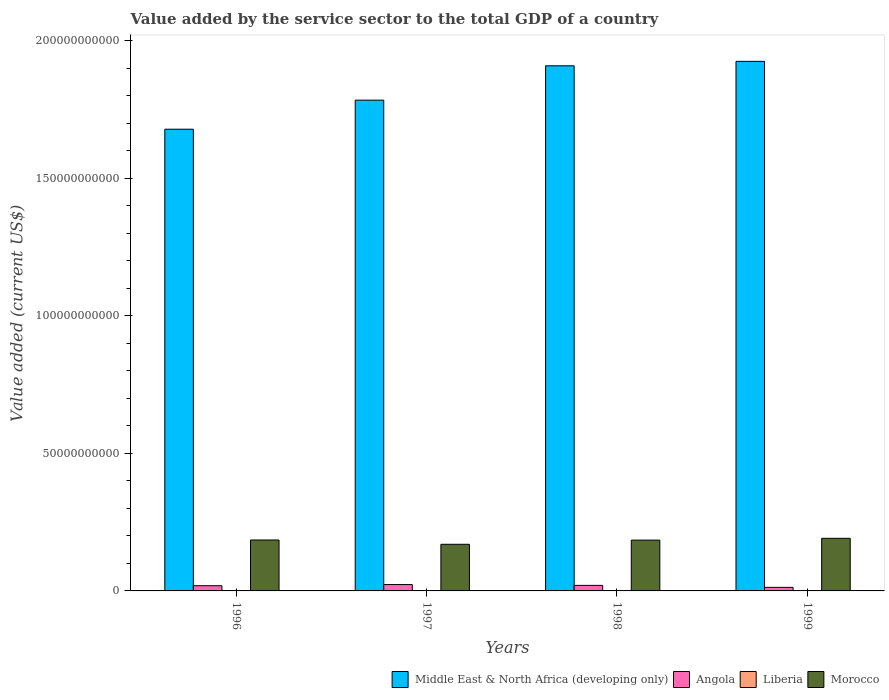How many different coloured bars are there?
Offer a terse response. 4. How many groups of bars are there?
Your answer should be very brief. 4. Are the number of bars per tick equal to the number of legend labels?
Provide a succinct answer. Yes. How many bars are there on the 3rd tick from the left?
Offer a terse response. 4. How many bars are there on the 1st tick from the right?
Keep it short and to the point. 4. In how many cases, is the number of bars for a given year not equal to the number of legend labels?
Your answer should be compact. 0. What is the value added by the service sector to the total GDP in Morocco in 1999?
Provide a short and direct response. 1.91e+1. Across all years, what is the maximum value added by the service sector to the total GDP in Liberia?
Provide a short and direct response. 7.34e+07. Across all years, what is the minimum value added by the service sector to the total GDP in Morocco?
Your response must be concise. 1.70e+1. What is the total value added by the service sector to the total GDP in Morocco in the graph?
Your answer should be very brief. 7.31e+1. What is the difference between the value added by the service sector to the total GDP in Morocco in 1997 and that in 1998?
Ensure brevity in your answer.  -1.51e+09. What is the difference between the value added by the service sector to the total GDP in Angola in 1997 and the value added by the service sector to the total GDP in Liberia in 1996?
Your answer should be very brief. 2.31e+09. What is the average value added by the service sector to the total GDP in Morocco per year?
Offer a terse response. 1.83e+1. In the year 1997, what is the difference between the value added by the service sector to the total GDP in Angola and value added by the service sector to the total GDP in Morocco?
Give a very brief answer. -1.46e+1. What is the ratio of the value added by the service sector to the total GDP in Morocco in 1996 to that in 1998?
Keep it short and to the point. 1. Is the value added by the service sector to the total GDP in Angola in 1997 less than that in 1999?
Keep it short and to the point. No. What is the difference between the highest and the second highest value added by the service sector to the total GDP in Liberia?
Ensure brevity in your answer.  2.21e+07. What is the difference between the highest and the lowest value added by the service sector to the total GDP in Morocco?
Your answer should be very brief. 2.17e+09. Is the sum of the value added by the service sector to the total GDP in Angola in 1997 and 1998 greater than the maximum value added by the service sector to the total GDP in Liberia across all years?
Keep it short and to the point. Yes. What does the 1st bar from the left in 1999 represents?
Your answer should be very brief. Middle East & North Africa (developing only). What does the 3rd bar from the right in 1999 represents?
Provide a succinct answer. Angola. Is it the case that in every year, the sum of the value added by the service sector to the total GDP in Middle East & North Africa (developing only) and value added by the service sector to the total GDP in Angola is greater than the value added by the service sector to the total GDP in Morocco?
Your response must be concise. Yes. How many bars are there?
Offer a terse response. 16. Are all the bars in the graph horizontal?
Your answer should be very brief. No. What is the difference between two consecutive major ticks on the Y-axis?
Your answer should be very brief. 5.00e+1. Does the graph contain grids?
Provide a succinct answer. No. How many legend labels are there?
Keep it short and to the point. 4. How are the legend labels stacked?
Provide a short and direct response. Horizontal. What is the title of the graph?
Offer a very short reply. Value added by the service sector to the total GDP of a country. What is the label or title of the Y-axis?
Provide a succinct answer. Value added (current US$). What is the Value added (current US$) of Middle East & North Africa (developing only) in 1996?
Your answer should be very brief. 1.68e+11. What is the Value added (current US$) of Angola in 1996?
Make the answer very short. 1.89e+09. What is the Value added (current US$) of Liberia in 1996?
Provide a succinct answer. 6.60e+06. What is the Value added (current US$) of Morocco in 1996?
Your answer should be very brief. 1.85e+1. What is the Value added (current US$) of Middle East & North Africa (developing only) in 1997?
Give a very brief answer. 1.78e+11. What is the Value added (current US$) of Angola in 1997?
Keep it short and to the point. 2.31e+09. What is the Value added (current US$) of Liberia in 1997?
Your answer should be very brief. 3.79e+07. What is the Value added (current US$) of Morocco in 1997?
Your answer should be compact. 1.70e+1. What is the Value added (current US$) of Middle East & North Africa (developing only) in 1998?
Ensure brevity in your answer.  1.91e+11. What is the Value added (current US$) of Angola in 1998?
Ensure brevity in your answer.  2.02e+09. What is the Value added (current US$) of Liberia in 1998?
Make the answer very short. 5.13e+07. What is the Value added (current US$) in Morocco in 1998?
Offer a terse response. 1.85e+1. What is the Value added (current US$) of Middle East & North Africa (developing only) in 1999?
Provide a short and direct response. 1.93e+11. What is the Value added (current US$) in Angola in 1999?
Provide a short and direct response. 1.29e+09. What is the Value added (current US$) of Liberia in 1999?
Your answer should be very brief. 7.34e+07. What is the Value added (current US$) of Morocco in 1999?
Your answer should be compact. 1.91e+1. Across all years, what is the maximum Value added (current US$) of Middle East & North Africa (developing only)?
Offer a terse response. 1.93e+11. Across all years, what is the maximum Value added (current US$) in Angola?
Provide a short and direct response. 2.31e+09. Across all years, what is the maximum Value added (current US$) in Liberia?
Your answer should be very brief. 7.34e+07. Across all years, what is the maximum Value added (current US$) of Morocco?
Keep it short and to the point. 1.91e+1. Across all years, what is the minimum Value added (current US$) of Middle East & North Africa (developing only)?
Your answer should be compact. 1.68e+11. Across all years, what is the minimum Value added (current US$) of Angola?
Give a very brief answer. 1.29e+09. Across all years, what is the minimum Value added (current US$) of Liberia?
Offer a terse response. 6.60e+06. Across all years, what is the minimum Value added (current US$) of Morocco?
Keep it short and to the point. 1.70e+1. What is the total Value added (current US$) of Middle East & North Africa (developing only) in the graph?
Your response must be concise. 7.30e+11. What is the total Value added (current US$) in Angola in the graph?
Your answer should be compact. 7.51e+09. What is the total Value added (current US$) in Liberia in the graph?
Your answer should be compact. 1.69e+08. What is the total Value added (current US$) of Morocco in the graph?
Offer a very short reply. 7.31e+1. What is the difference between the Value added (current US$) of Middle East & North Africa (developing only) in 1996 and that in 1997?
Your response must be concise. -1.06e+1. What is the difference between the Value added (current US$) of Angola in 1996 and that in 1997?
Ensure brevity in your answer.  -4.20e+08. What is the difference between the Value added (current US$) of Liberia in 1996 and that in 1997?
Offer a very short reply. -3.13e+07. What is the difference between the Value added (current US$) of Morocco in 1996 and that in 1997?
Ensure brevity in your answer.  1.56e+09. What is the difference between the Value added (current US$) in Middle East & North Africa (developing only) in 1996 and that in 1998?
Provide a short and direct response. -2.31e+1. What is the difference between the Value added (current US$) of Angola in 1996 and that in 1998?
Offer a very short reply. -1.23e+08. What is the difference between the Value added (current US$) in Liberia in 1996 and that in 1998?
Your answer should be very brief. -4.47e+07. What is the difference between the Value added (current US$) in Morocco in 1996 and that in 1998?
Your answer should be very brief. 4.87e+07. What is the difference between the Value added (current US$) in Middle East & North Africa (developing only) in 1996 and that in 1999?
Ensure brevity in your answer.  -2.47e+1. What is the difference between the Value added (current US$) in Angola in 1996 and that in 1999?
Your response must be concise. 6.02e+08. What is the difference between the Value added (current US$) of Liberia in 1996 and that in 1999?
Provide a short and direct response. -6.68e+07. What is the difference between the Value added (current US$) of Morocco in 1996 and that in 1999?
Offer a very short reply. -6.11e+08. What is the difference between the Value added (current US$) in Middle East & North Africa (developing only) in 1997 and that in 1998?
Provide a short and direct response. -1.25e+1. What is the difference between the Value added (current US$) of Angola in 1997 and that in 1998?
Your answer should be very brief. 2.97e+08. What is the difference between the Value added (current US$) of Liberia in 1997 and that in 1998?
Keep it short and to the point. -1.34e+07. What is the difference between the Value added (current US$) of Morocco in 1997 and that in 1998?
Ensure brevity in your answer.  -1.51e+09. What is the difference between the Value added (current US$) of Middle East & North Africa (developing only) in 1997 and that in 1999?
Offer a terse response. -1.41e+1. What is the difference between the Value added (current US$) of Angola in 1997 and that in 1999?
Keep it short and to the point. 1.02e+09. What is the difference between the Value added (current US$) in Liberia in 1997 and that in 1999?
Provide a succinct answer. -3.55e+07. What is the difference between the Value added (current US$) of Morocco in 1997 and that in 1999?
Provide a short and direct response. -2.17e+09. What is the difference between the Value added (current US$) in Middle East & North Africa (developing only) in 1998 and that in 1999?
Your answer should be very brief. -1.62e+09. What is the difference between the Value added (current US$) of Angola in 1998 and that in 1999?
Offer a very short reply. 7.25e+08. What is the difference between the Value added (current US$) in Liberia in 1998 and that in 1999?
Make the answer very short. -2.21e+07. What is the difference between the Value added (current US$) of Morocco in 1998 and that in 1999?
Keep it short and to the point. -6.60e+08. What is the difference between the Value added (current US$) of Middle East & North Africa (developing only) in 1996 and the Value added (current US$) of Angola in 1997?
Make the answer very short. 1.66e+11. What is the difference between the Value added (current US$) of Middle East & North Africa (developing only) in 1996 and the Value added (current US$) of Liberia in 1997?
Ensure brevity in your answer.  1.68e+11. What is the difference between the Value added (current US$) of Middle East & North Africa (developing only) in 1996 and the Value added (current US$) of Morocco in 1997?
Ensure brevity in your answer.  1.51e+11. What is the difference between the Value added (current US$) of Angola in 1996 and the Value added (current US$) of Liberia in 1997?
Keep it short and to the point. 1.86e+09. What is the difference between the Value added (current US$) in Angola in 1996 and the Value added (current US$) in Morocco in 1997?
Ensure brevity in your answer.  -1.51e+1. What is the difference between the Value added (current US$) of Liberia in 1996 and the Value added (current US$) of Morocco in 1997?
Your response must be concise. -1.70e+1. What is the difference between the Value added (current US$) in Middle East & North Africa (developing only) in 1996 and the Value added (current US$) in Angola in 1998?
Keep it short and to the point. 1.66e+11. What is the difference between the Value added (current US$) of Middle East & North Africa (developing only) in 1996 and the Value added (current US$) of Liberia in 1998?
Your response must be concise. 1.68e+11. What is the difference between the Value added (current US$) of Middle East & North Africa (developing only) in 1996 and the Value added (current US$) of Morocco in 1998?
Ensure brevity in your answer.  1.49e+11. What is the difference between the Value added (current US$) of Angola in 1996 and the Value added (current US$) of Liberia in 1998?
Offer a terse response. 1.84e+09. What is the difference between the Value added (current US$) in Angola in 1996 and the Value added (current US$) in Morocco in 1998?
Offer a terse response. -1.66e+1. What is the difference between the Value added (current US$) in Liberia in 1996 and the Value added (current US$) in Morocco in 1998?
Keep it short and to the point. -1.85e+1. What is the difference between the Value added (current US$) in Middle East & North Africa (developing only) in 1996 and the Value added (current US$) in Angola in 1999?
Your response must be concise. 1.67e+11. What is the difference between the Value added (current US$) in Middle East & North Africa (developing only) in 1996 and the Value added (current US$) in Liberia in 1999?
Provide a succinct answer. 1.68e+11. What is the difference between the Value added (current US$) of Middle East & North Africa (developing only) in 1996 and the Value added (current US$) of Morocco in 1999?
Your answer should be compact. 1.49e+11. What is the difference between the Value added (current US$) of Angola in 1996 and the Value added (current US$) of Liberia in 1999?
Provide a succinct answer. 1.82e+09. What is the difference between the Value added (current US$) of Angola in 1996 and the Value added (current US$) of Morocco in 1999?
Give a very brief answer. -1.72e+1. What is the difference between the Value added (current US$) of Liberia in 1996 and the Value added (current US$) of Morocco in 1999?
Offer a very short reply. -1.91e+1. What is the difference between the Value added (current US$) in Middle East & North Africa (developing only) in 1997 and the Value added (current US$) in Angola in 1998?
Make the answer very short. 1.76e+11. What is the difference between the Value added (current US$) of Middle East & North Africa (developing only) in 1997 and the Value added (current US$) of Liberia in 1998?
Offer a very short reply. 1.78e+11. What is the difference between the Value added (current US$) in Middle East & North Africa (developing only) in 1997 and the Value added (current US$) in Morocco in 1998?
Provide a short and direct response. 1.60e+11. What is the difference between the Value added (current US$) in Angola in 1997 and the Value added (current US$) in Liberia in 1998?
Your response must be concise. 2.26e+09. What is the difference between the Value added (current US$) of Angola in 1997 and the Value added (current US$) of Morocco in 1998?
Your response must be concise. -1.62e+1. What is the difference between the Value added (current US$) in Liberia in 1997 and the Value added (current US$) in Morocco in 1998?
Keep it short and to the point. -1.84e+1. What is the difference between the Value added (current US$) in Middle East & North Africa (developing only) in 1997 and the Value added (current US$) in Angola in 1999?
Your answer should be compact. 1.77e+11. What is the difference between the Value added (current US$) of Middle East & North Africa (developing only) in 1997 and the Value added (current US$) of Liberia in 1999?
Provide a succinct answer. 1.78e+11. What is the difference between the Value added (current US$) in Middle East & North Africa (developing only) in 1997 and the Value added (current US$) in Morocco in 1999?
Give a very brief answer. 1.59e+11. What is the difference between the Value added (current US$) of Angola in 1997 and the Value added (current US$) of Liberia in 1999?
Your answer should be very brief. 2.24e+09. What is the difference between the Value added (current US$) of Angola in 1997 and the Value added (current US$) of Morocco in 1999?
Provide a succinct answer. -1.68e+1. What is the difference between the Value added (current US$) in Liberia in 1997 and the Value added (current US$) in Morocco in 1999?
Provide a short and direct response. -1.91e+1. What is the difference between the Value added (current US$) of Middle East & North Africa (developing only) in 1998 and the Value added (current US$) of Angola in 1999?
Your answer should be very brief. 1.90e+11. What is the difference between the Value added (current US$) of Middle East & North Africa (developing only) in 1998 and the Value added (current US$) of Liberia in 1999?
Provide a short and direct response. 1.91e+11. What is the difference between the Value added (current US$) of Middle East & North Africa (developing only) in 1998 and the Value added (current US$) of Morocco in 1999?
Ensure brevity in your answer.  1.72e+11. What is the difference between the Value added (current US$) in Angola in 1998 and the Value added (current US$) in Liberia in 1999?
Offer a terse response. 1.94e+09. What is the difference between the Value added (current US$) in Angola in 1998 and the Value added (current US$) in Morocco in 1999?
Provide a succinct answer. -1.71e+1. What is the difference between the Value added (current US$) in Liberia in 1998 and the Value added (current US$) in Morocco in 1999?
Your answer should be very brief. -1.91e+1. What is the average Value added (current US$) of Middle East & North Africa (developing only) per year?
Your answer should be compact. 1.82e+11. What is the average Value added (current US$) in Angola per year?
Ensure brevity in your answer.  1.88e+09. What is the average Value added (current US$) of Liberia per year?
Your answer should be very brief. 4.23e+07. What is the average Value added (current US$) of Morocco per year?
Ensure brevity in your answer.  1.83e+1. In the year 1996, what is the difference between the Value added (current US$) in Middle East & North Africa (developing only) and Value added (current US$) in Angola?
Offer a terse response. 1.66e+11. In the year 1996, what is the difference between the Value added (current US$) of Middle East & North Africa (developing only) and Value added (current US$) of Liberia?
Offer a terse response. 1.68e+11. In the year 1996, what is the difference between the Value added (current US$) in Middle East & North Africa (developing only) and Value added (current US$) in Morocco?
Keep it short and to the point. 1.49e+11. In the year 1996, what is the difference between the Value added (current US$) of Angola and Value added (current US$) of Liberia?
Provide a short and direct response. 1.89e+09. In the year 1996, what is the difference between the Value added (current US$) of Angola and Value added (current US$) of Morocco?
Provide a succinct answer. -1.66e+1. In the year 1996, what is the difference between the Value added (current US$) in Liberia and Value added (current US$) in Morocco?
Your answer should be compact. -1.85e+1. In the year 1997, what is the difference between the Value added (current US$) of Middle East & North Africa (developing only) and Value added (current US$) of Angola?
Your answer should be very brief. 1.76e+11. In the year 1997, what is the difference between the Value added (current US$) in Middle East & North Africa (developing only) and Value added (current US$) in Liberia?
Provide a succinct answer. 1.78e+11. In the year 1997, what is the difference between the Value added (current US$) of Middle East & North Africa (developing only) and Value added (current US$) of Morocco?
Give a very brief answer. 1.62e+11. In the year 1997, what is the difference between the Value added (current US$) in Angola and Value added (current US$) in Liberia?
Make the answer very short. 2.28e+09. In the year 1997, what is the difference between the Value added (current US$) in Angola and Value added (current US$) in Morocco?
Provide a succinct answer. -1.46e+1. In the year 1997, what is the difference between the Value added (current US$) in Liberia and Value added (current US$) in Morocco?
Provide a succinct answer. -1.69e+1. In the year 1998, what is the difference between the Value added (current US$) of Middle East & North Africa (developing only) and Value added (current US$) of Angola?
Give a very brief answer. 1.89e+11. In the year 1998, what is the difference between the Value added (current US$) of Middle East & North Africa (developing only) and Value added (current US$) of Liberia?
Make the answer very short. 1.91e+11. In the year 1998, what is the difference between the Value added (current US$) in Middle East & North Africa (developing only) and Value added (current US$) in Morocco?
Your response must be concise. 1.72e+11. In the year 1998, what is the difference between the Value added (current US$) in Angola and Value added (current US$) in Liberia?
Your answer should be very brief. 1.97e+09. In the year 1998, what is the difference between the Value added (current US$) in Angola and Value added (current US$) in Morocco?
Provide a short and direct response. -1.65e+1. In the year 1998, what is the difference between the Value added (current US$) of Liberia and Value added (current US$) of Morocco?
Provide a succinct answer. -1.84e+1. In the year 1999, what is the difference between the Value added (current US$) of Middle East & North Africa (developing only) and Value added (current US$) of Angola?
Offer a very short reply. 1.91e+11. In the year 1999, what is the difference between the Value added (current US$) in Middle East & North Africa (developing only) and Value added (current US$) in Liberia?
Keep it short and to the point. 1.93e+11. In the year 1999, what is the difference between the Value added (current US$) in Middle East & North Africa (developing only) and Value added (current US$) in Morocco?
Ensure brevity in your answer.  1.73e+11. In the year 1999, what is the difference between the Value added (current US$) of Angola and Value added (current US$) of Liberia?
Ensure brevity in your answer.  1.22e+09. In the year 1999, what is the difference between the Value added (current US$) of Angola and Value added (current US$) of Morocco?
Ensure brevity in your answer.  -1.78e+1. In the year 1999, what is the difference between the Value added (current US$) of Liberia and Value added (current US$) of Morocco?
Offer a terse response. -1.91e+1. What is the ratio of the Value added (current US$) of Middle East & North Africa (developing only) in 1996 to that in 1997?
Offer a very short reply. 0.94. What is the ratio of the Value added (current US$) of Angola in 1996 to that in 1997?
Your answer should be compact. 0.82. What is the ratio of the Value added (current US$) of Liberia in 1996 to that in 1997?
Keep it short and to the point. 0.17. What is the ratio of the Value added (current US$) of Morocco in 1996 to that in 1997?
Offer a terse response. 1.09. What is the ratio of the Value added (current US$) of Middle East & North Africa (developing only) in 1996 to that in 1998?
Offer a very short reply. 0.88. What is the ratio of the Value added (current US$) in Angola in 1996 to that in 1998?
Provide a succinct answer. 0.94. What is the ratio of the Value added (current US$) of Liberia in 1996 to that in 1998?
Offer a very short reply. 0.13. What is the ratio of the Value added (current US$) in Middle East & North Africa (developing only) in 1996 to that in 1999?
Provide a short and direct response. 0.87. What is the ratio of the Value added (current US$) in Angola in 1996 to that in 1999?
Your answer should be very brief. 1.47. What is the ratio of the Value added (current US$) in Liberia in 1996 to that in 1999?
Your response must be concise. 0.09. What is the ratio of the Value added (current US$) in Morocco in 1996 to that in 1999?
Keep it short and to the point. 0.97. What is the ratio of the Value added (current US$) in Middle East & North Africa (developing only) in 1997 to that in 1998?
Ensure brevity in your answer.  0.93. What is the ratio of the Value added (current US$) in Angola in 1997 to that in 1998?
Your answer should be very brief. 1.15. What is the ratio of the Value added (current US$) in Liberia in 1997 to that in 1998?
Give a very brief answer. 0.74. What is the ratio of the Value added (current US$) of Morocco in 1997 to that in 1998?
Provide a succinct answer. 0.92. What is the ratio of the Value added (current US$) of Middle East & North Africa (developing only) in 1997 to that in 1999?
Ensure brevity in your answer.  0.93. What is the ratio of the Value added (current US$) of Angola in 1997 to that in 1999?
Give a very brief answer. 1.79. What is the ratio of the Value added (current US$) of Liberia in 1997 to that in 1999?
Offer a terse response. 0.52. What is the ratio of the Value added (current US$) of Morocco in 1997 to that in 1999?
Your answer should be very brief. 0.89. What is the ratio of the Value added (current US$) of Middle East & North Africa (developing only) in 1998 to that in 1999?
Provide a succinct answer. 0.99. What is the ratio of the Value added (current US$) of Angola in 1998 to that in 1999?
Provide a short and direct response. 1.56. What is the ratio of the Value added (current US$) in Liberia in 1998 to that in 1999?
Ensure brevity in your answer.  0.7. What is the ratio of the Value added (current US$) in Morocco in 1998 to that in 1999?
Provide a short and direct response. 0.97. What is the difference between the highest and the second highest Value added (current US$) in Middle East & North Africa (developing only)?
Make the answer very short. 1.62e+09. What is the difference between the highest and the second highest Value added (current US$) of Angola?
Provide a short and direct response. 2.97e+08. What is the difference between the highest and the second highest Value added (current US$) of Liberia?
Make the answer very short. 2.21e+07. What is the difference between the highest and the second highest Value added (current US$) in Morocco?
Keep it short and to the point. 6.11e+08. What is the difference between the highest and the lowest Value added (current US$) of Middle East & North Africa (developing only)?
Make the answer very short. 2.47e+1. What is the difference between the highest and the lowest Value added (current US$) of Angola?
Provide a succinct answer. 1.02e+09. What is the difference between the highest and the lowest Value added (current US$) in Liberia?
Ensure brevity in your answer.  6.68e+07. What is the difference between the highest and the lowest Value added (current US$) of Morocco?
Provide a succinct answer. 2.17e+09. 